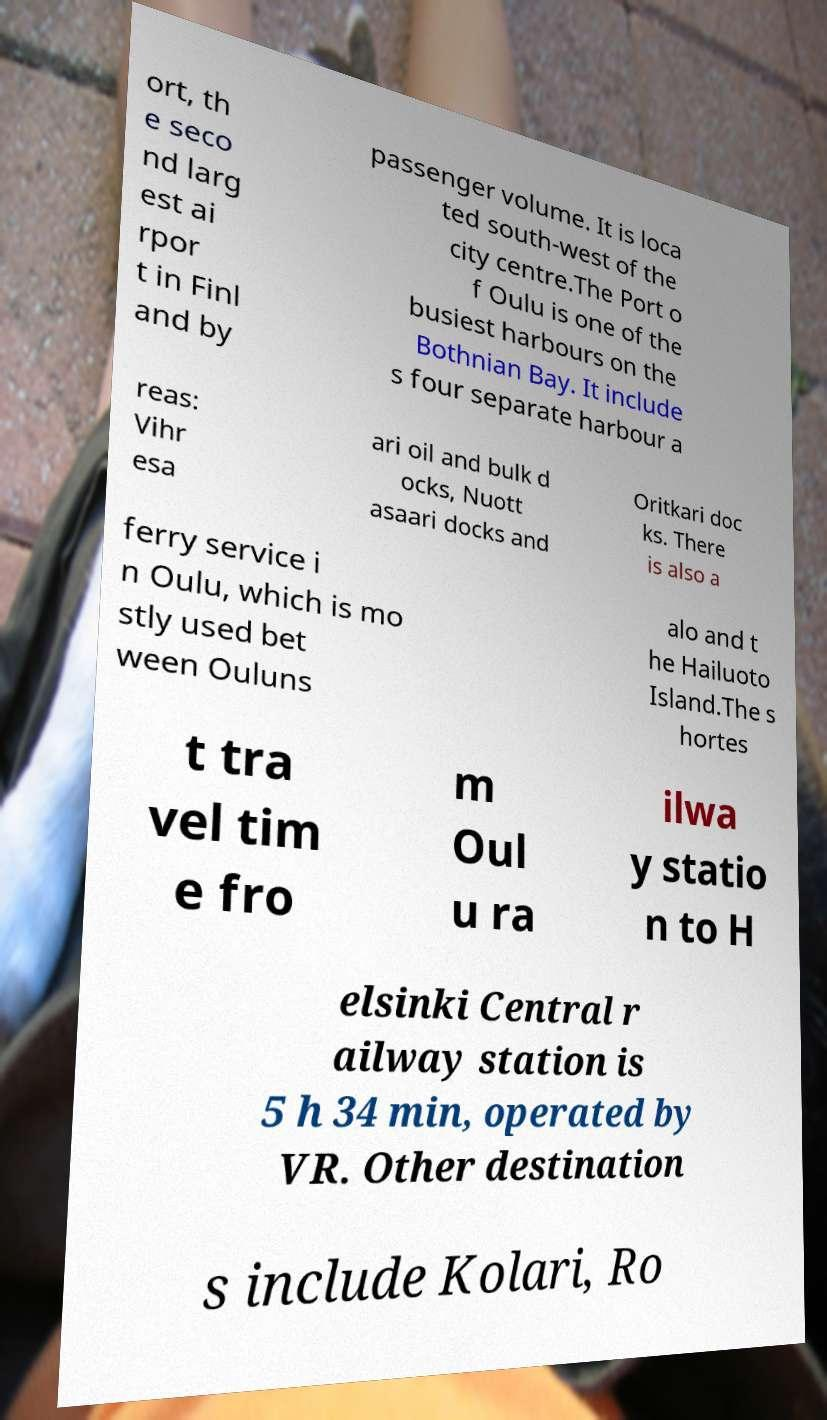I need the written content from this picture converted into text. Can you do that? ort, th e seco nd larg est ai rpor t in Finl and by passenger volume. It is loca ted south-west of the city centre.The Port o f Oulu is one of the busiest harbours on the Bothnian Bay. It include s four separate harbour a reas: Vihr esa ari oil and bulk d ocks, Nuott asaari docks and Oritkari doc ks. There is also a ferry service i n Oulu, which is mo stly used bet ween Ouluns alo and t he Hailuoto Island.The s hortes t tra vel tim e fro m Oul u ra ilwa y statio n to H elsinki Central r ailway station is 5 h 34 min, operated by VR. Other destination s include Kolari, Ro 